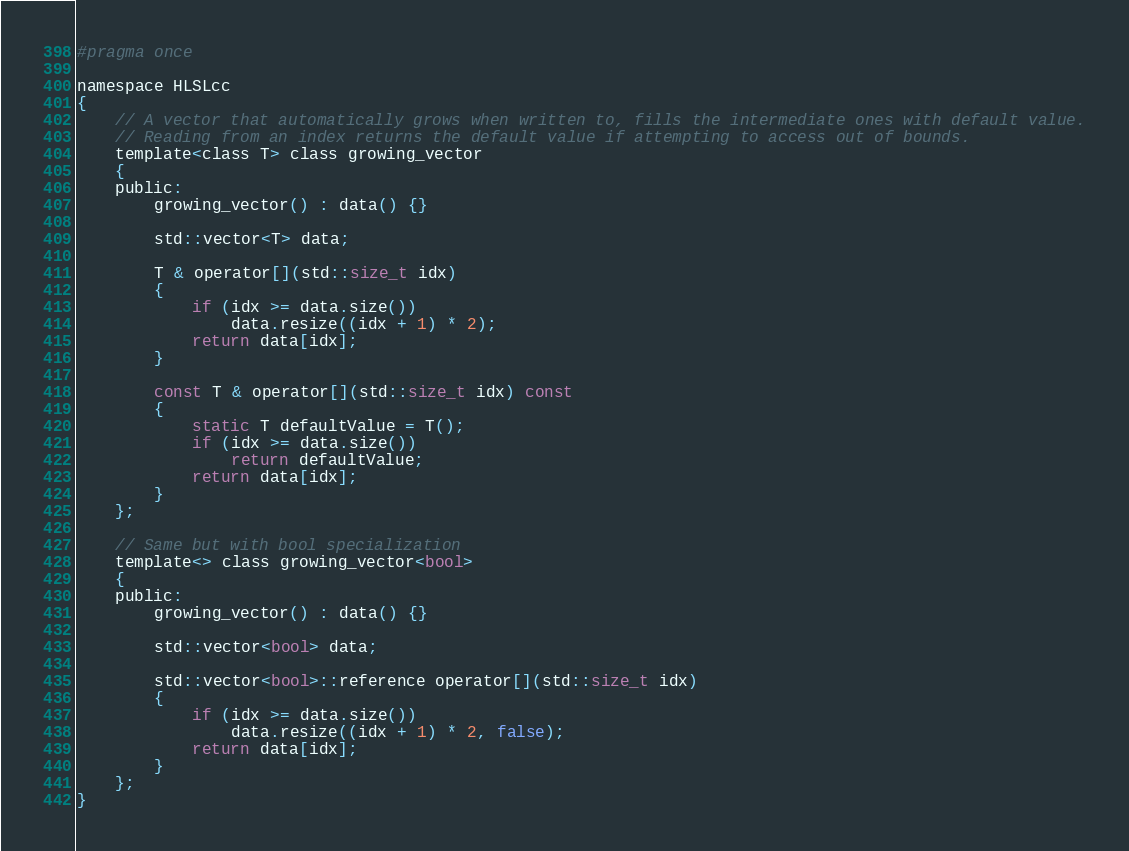Convert code to text. <code><loc_0><loc_0><loc_500><loc_500><_C_>#pragma once

namespace HLSLcc
{
    // A vector that automatically grows when written to, fills the intermediate ones with default value.
    // Reading from an index returns the default value if attempting to access out of bounds.
    template<class T> class growing_vector
    {
    public:
        growing_vector() : data() {}

        std::vector<T> data;

        T & operator[](std::size_t idx)
        {
            if (idx >= data.size())
                data.resize((idx + 1) * 2);
            return data[idx];
        }

        const T & operator[](std::size_t idx) const
        {
            static T defaultValue = T();
            if (idx >= data.size())
                return defaultValue;
            return data[idx];
        }
    };

    // Same but with bool specialization
    template<> class growing_vector<bool>
    {
    public:
        growing_vector() : data() {}

        std::vector<bool> data;

        std::vector<bool>::reference operator[](std::size_t idx)
        {
            if (idx >= data.size())
                data.resize((idx + 1) * 2, false);
            return data[idx];
        }
    };
}
</code> 